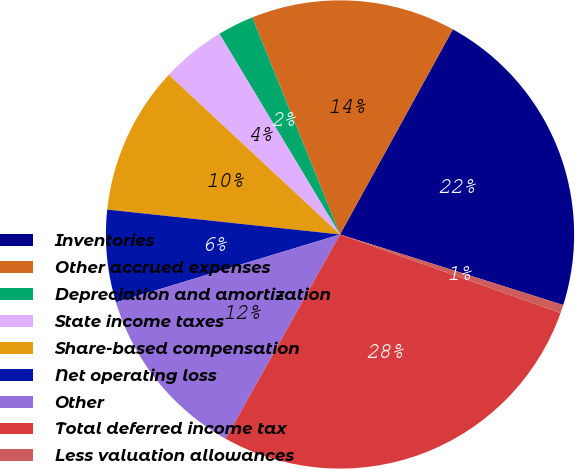Convert chart to OTSL. <chart><loc_0><loc_0><loc_500><loc_500><pie_chart><fcel>Inventories<fcel>Other accrued expenses<fcel>Depreciation and amortization<fcel>State income taxes<fcel>Share-based compensation<fcel>Net operating loss<fcel>Other<fcel>Total deferred income tax<fcel>Less valuation allowances<nl><fcel>21.87%<fcel>14.12%<fcel>2.5%<fcel>4.44%<fcel>10.25%<fcel>6.38%<fcel>12.19%<fcel>27.68%<fcel>0.57%<nl></chart> 